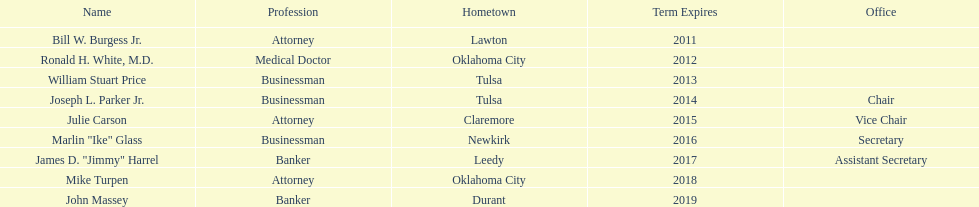How many members had businessman listed as their profession? 3. 